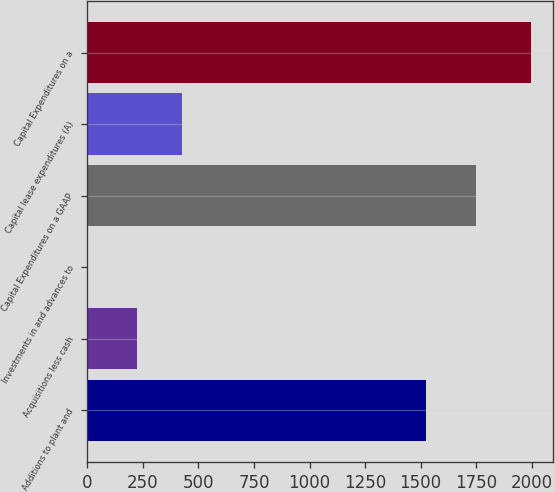Convert chart. <chart><loc_0><loc_0><loc_500><loc_500><bar_chart><fcel>Additions to plant and<fcel>Acquisitions less cash<fcel>Investments in and advances to<fcel>Capital Expenditures on a GAAP<fcel>Capital lease expenditures (A)<fcel>Capital Expenditures on a<nl><fcel>1524.2<fcel>224.9<fcel>1.3<fcel>1747.8<fcel>424.44<fcel>1996.7<nl></chart> 